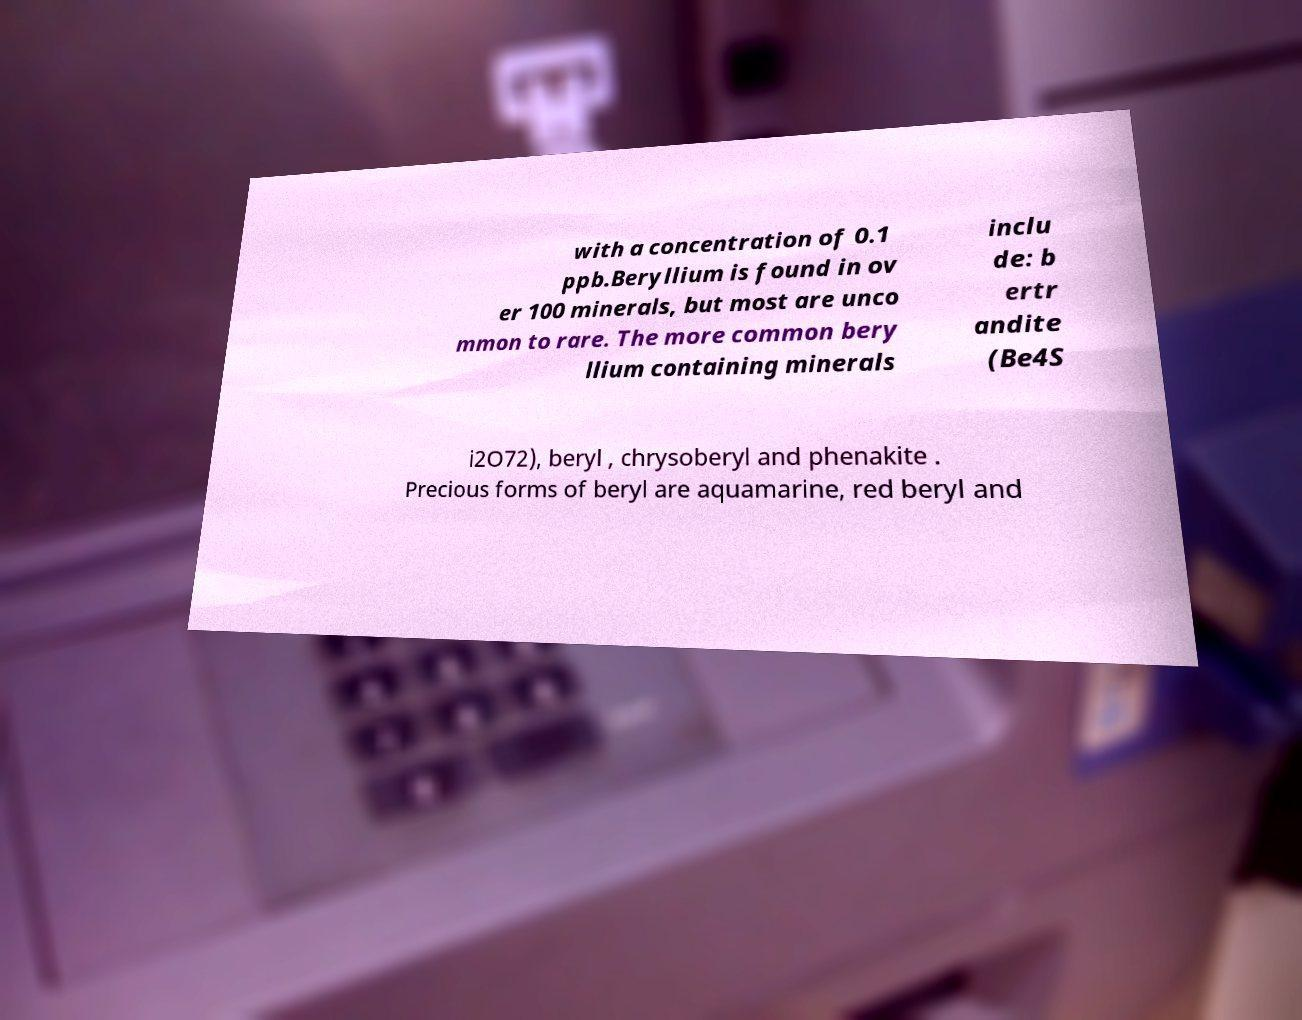I need the written content from this picture converted into text. Can you do that? with a concentration of 0.1 ppb.Beryllium is found in ov er 100 minerals, but most are unco mmon to rare. The more common bery llium containing minerals inclu de: b ertr andite (Be4S i2O72), beryl , chrysoberyl and phenakite . Precious forms of beryl are aquamarine, red beryl and 